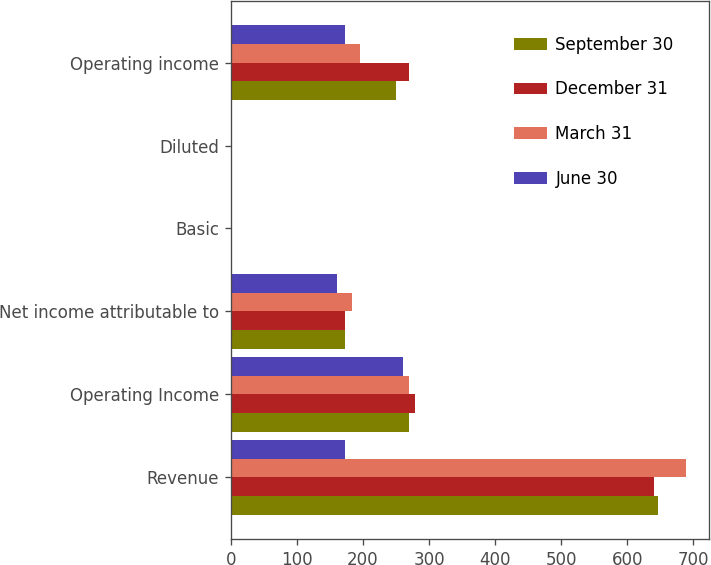Convert chart to OTSL. <chart><loc_0><loc_0><loc_500><loc_500><stacked_bar_chart><ecel><fcel>Revenue<fcel>Operating Income<fcel>Net income attributable to<fcel>Basic<fcel>Diluted<fcel>Operating income<nl><fcel>September 30<fcel>646.8<fcel>269<fcel>173.5<fcel>0.78<fcel>0.76<fcel>250.1<nl><fcel>December 31<fcel>640.8<fcel>278.5<fcel>172.5<fcel>0.77<fcel>0.76<fcel>270.1<nl><fcel>March 31<fcel>688.5<fcel>269.7<fcel>183.9<fcel>0.83<fcel>0.81<fcel>196.1<nl><fcel>June 30<fcel>173.5<fcel>260.2<fcel>160.1<fcel>0.72<fcel>0.7<fcel>172.1<nl></chart> 